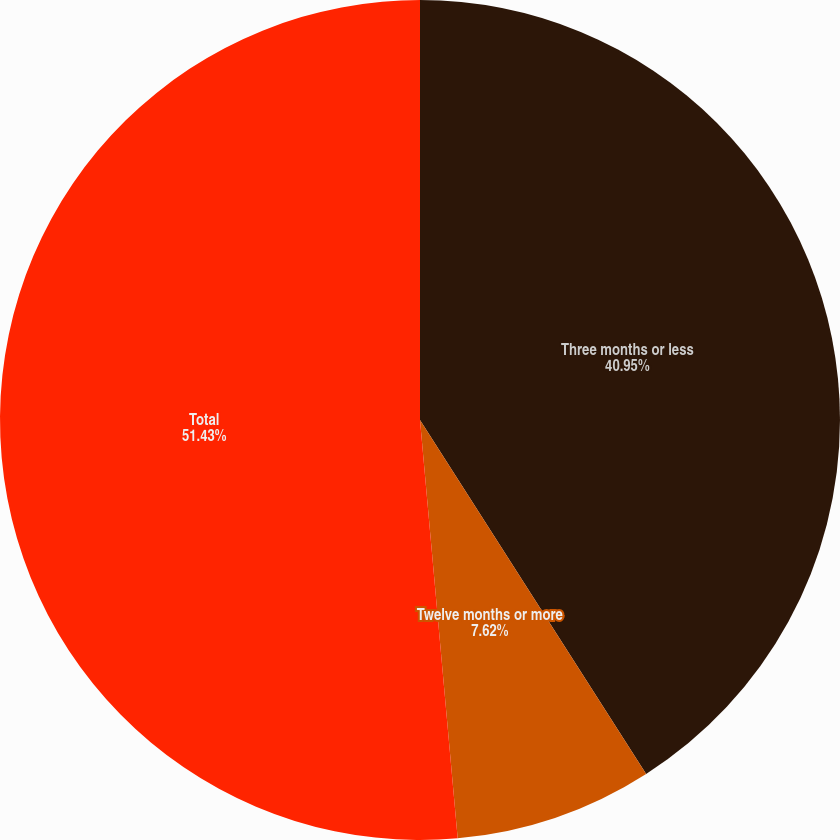Convert chart to OTSL. <chart><loc_0><loc_0><loc_500><loc_500><pie_chart><fcel>Three months or less<fcel>Twelve months or more<fcel>Total<nl><fcel>40.95%<fcel>7.62%<fcel>51.43%<nl></chart> 